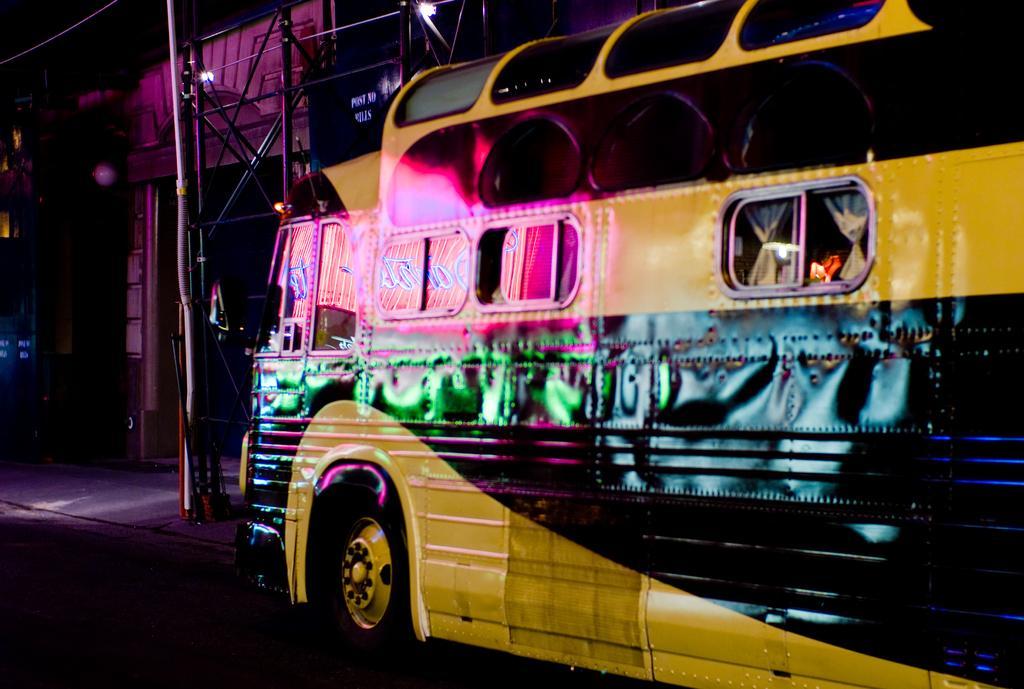Describe this image in one or two sentences. In this image we can see one building, one vehicle on the road, some poles in front of the building, one wire at the top, footpath near the road and the background is dark. 